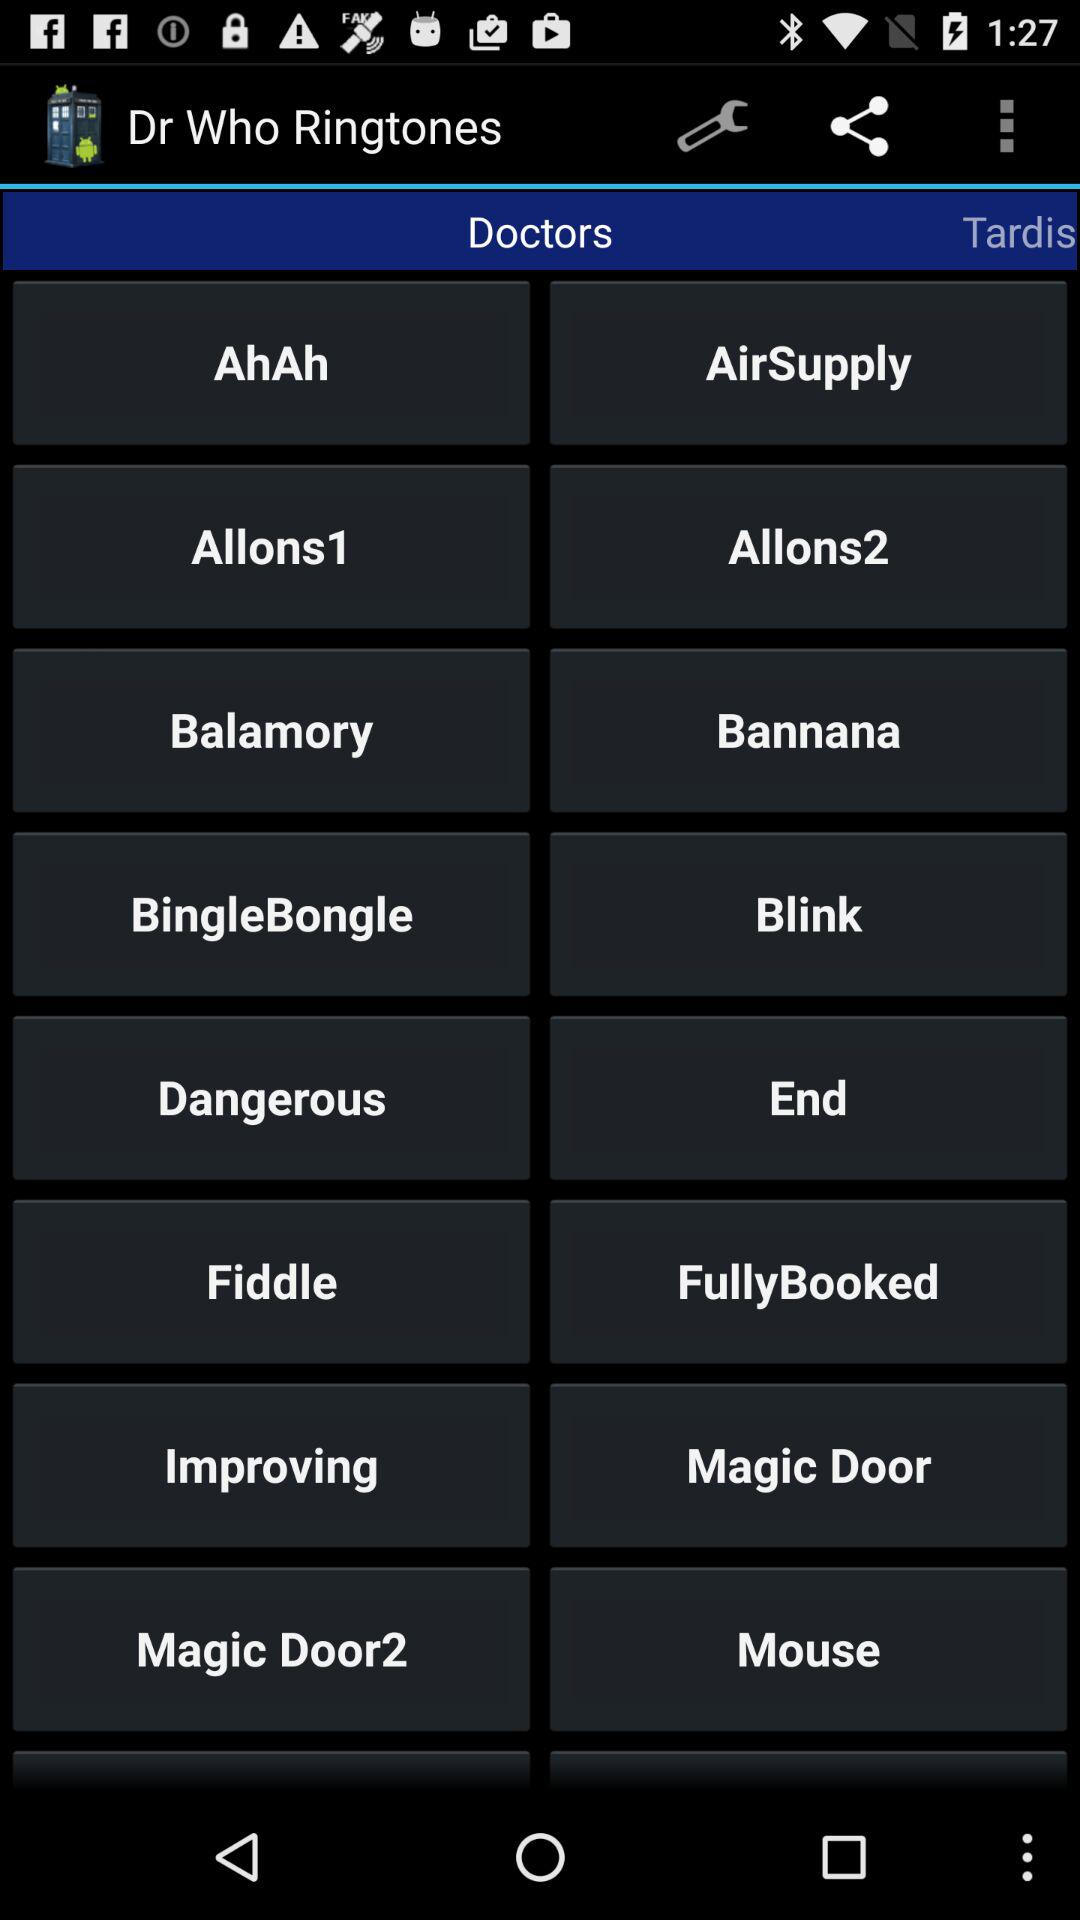Through which applications can this be shared?
When the provided information is insufficient, respond with <no answer>. <no answer> 